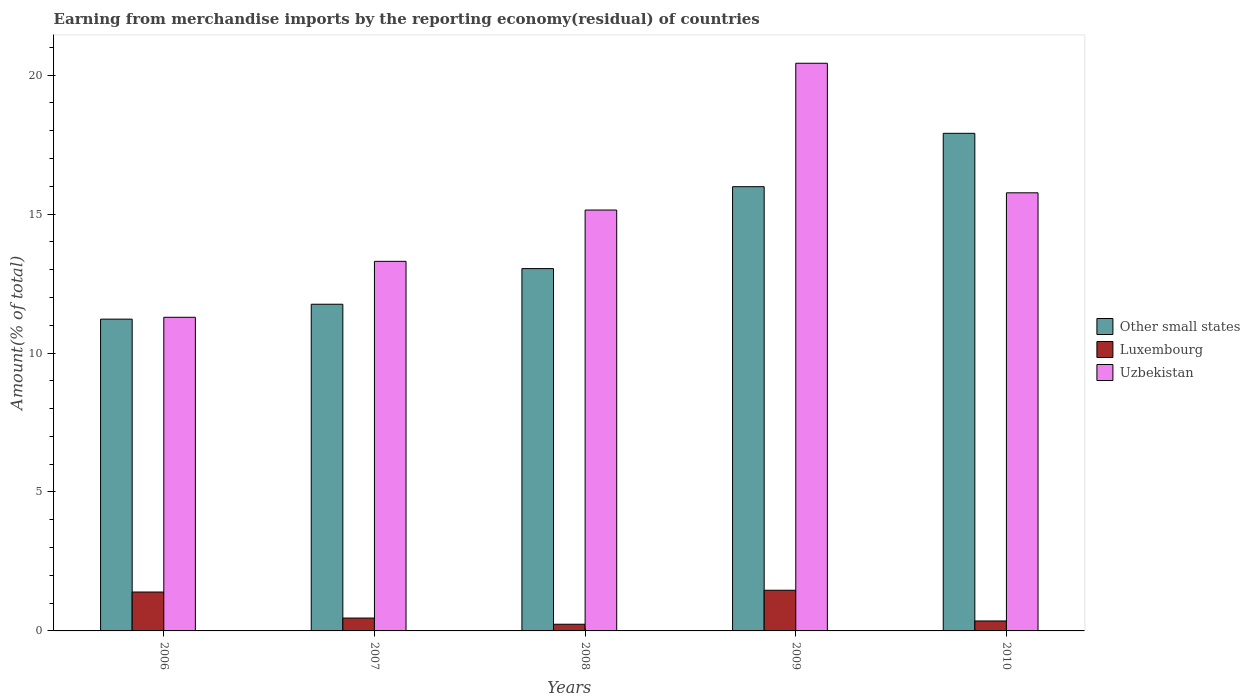How many different coloured bars are there?
Provide a short and direct response. 3. Are the number of bars on each tick of the X-axis equal?
Your response must be concise. Yes. What is the percentage of amount earned from merchandise imports in Other small states in 2009?
Provide a short and direct response. 15.99. Across all years, what is the maximum percentage of amount earned from merchandise imports in Luxembourg?
Give a very brief answer. 1.46. Across all years, what is the minimum percentage of amount earned from merchandise imports in Other small states?
Give a very brief answer. 11.22. In which year was the percentage of amount earned from merchandise imports in Uzbekistan minimum?
Keep it short and to the point. 2006. What is the total percentage of amount earned from merchandise imports in Other small states in the graph?
Your answer should be compact. 69.9. What is the difference between the percentage of amount earned from merchandise imports in Luxembourg in 2008 and that in 2010?
Keep it short and to the point. -0.12. What is the difference between the percentage of amount earned from merchandise imports in Other small states in 2007 and the percentage of amount earned from merchandise imports in Luxembourg in 2010?
Make the answer very short. 11.4. What is the average percentage of amount earned from merchandise imports in Luxembourg per year?
Offer a very short reply. 0.78. In the year 2007, what is the difference between the percentage of amount earned from merchandise imports in Uzbekistan and percentage of amount earned from merchandise imports in Other small states?
Keep it short and to the point. 1.54. What is the ratio of the percentage of amount earned from merchandise imports in Uzbekistan in 2009 to that in 2010?
Offer a very short reply. 1.3. Is the percentage of amount earned from merchandise imports in Luxembourg in 2007 less than that in 2010?
Offer a very short reply. No. Is the difference between the percentage of amount earned from merchandise imports in Uzbekistan in 2006 and 2010 greater than the difference between the percentage of amount earned from merchandise imports in Other small states in 2006 and 2010?
Provide a succinct answer. Yes. What is the difference between the highest and the second highest percentage of amount earned from merchandise imports in Uzbekistan?
Your answer should be compact. 4.66. What is the difference between the highest and the lowest percentage of amount earned from merchandise imports in Uzbekistan?
Offer a terse response. 9.14. In how many years, is the percentage of amount earned from merchandise imports in Luxembourg greater than the average percentage of amount earned from merchandise imports in Luxembourg taken over all years?
Give a very brief answer. 2. What does the 3rd bar from the left in 2009 represents?
Your answer should be compact. Uzbekistan. What does the 1st bar from the right in 2007 represents?
Provide a succinct answer. Uzbekistan. How many bars are there?
Ensure brevity in your answer.  15. What is the difference between two consecutive major ticks on the Y-axis?
Give a very brief answer. 5. Does the graph contain any zero values?
Your response must be concise. No. Where does the legend appear in the graph?
Offer a very short reply. Center right. How are the legend labels stacked?
Ensure brevity in your answer.  Vertical. What is the title of the graph?
Offer a very short reply. Earning from merchandise imports by the reporting economy(residual) of countries. Does "Rwanda" appear as one of the legend labels in the graph?
Make the answer very short. No. What is the label or title of the Y-axis?
Give a very brief answer. Amount(% of total). What is the Amount(% of total) in Other small states in 2006?
Your answer should be compact. 11.22. What is the Amount(% of total) of Luxembourg in 2006?
Ensure brevity in your answer.  1.4. What is the Amount(% of total) of Uzbekistan in 2006?
Offer a very short reply. 11.29. What is the Amount(% of total) in Other small states in 2007?
Give a very brief answer. 11.75. What is the Amount(% of total) of Luxembourg in 2007?
Ensure brevity in your answer.  0.46. What is the Amount(% of total) in Uzbekistan in 2007?
Make the answer very short. 13.3. What is the Amount(% of total) of Other small states in 2008?
Your answer should be very brief. 13.04. What is the Amount(% of total) in Luxembourg in 2008?
Your answer should be compact. 0.24. What is the Amount(% of total) of Uzbekistan in 2008?
Offer a very short reply. 15.14. What is the Amount(% of total) of Other small states in 2009?
Offer a terse response. 15.99. What is the Amount(% of total) of Luxembourg in 2009?
Offer a very short reply. 1.46. What is the Amount(% of total) of Uzbekistan in 2009?
Your response must be concise. 20.43. What is the Amount(% of total) of Other small states in 2010?
Offer a very short reply. 17.91. What is the Amount(% of total) of Luxembourg in 2010?
Provide a succinct answer. 0.36. What is the Amount(% of total) in Uzbekistan in 2010?
Offer a very short reply. 15.76. Across all years, what is the maximum Amount(% of total) of Other small states?
Provide a succinct answer. 17.91. Across all years, what is the maximum Amount(% of total) of Luxembourg?
Keep it short and to the point. 1.46. Across all years, what is the maximum Amount(% of total) in Uzbekistan?
Provide a short and direct response. 20.43. Across all years, what is the minimum Amount(% of total) in Other small states?
Your answer should be very brief. 11.22. Across all years, what is the minimum Amount(% of total) in Luxembourg?
Your answer should be very brief. 0.24. Across all years, what is the minimum Amount(% of total) of Uzbekistan?
Your answer should be very brief. 11.29. What is the total Amount(% of total) of Other small states in the graph?
Give a very brief answer. 69.9. What is the total Amount(% of total) of Luxembourg in the graph?
Offer a terse response. 3.92. What is the total Amount(% of total) in Uzbekistan in the graph?
Your answer should be very brief. 75.92. What is the difference between the Amount(% of total) of Other small states in 2006 and that in 2007?
Give a very brief answer. -0.54. What is the difference between the Amount(% of total) of Luxembourg in 2006 and that in 2007?
Your response must be concise. 0.94. What is the difference between the Amount(% of total) in Uzbekistan in 2006 and that in 2007?
Offer a terse response. -2.01. What is the difference between the Amount(% of total) in Other small states in 2006 and that in 2008?
Give a very brief answer. -1.82. What is the difference between the Amount(% of total) in Luxembourg in 2006 and that in 2008?
Offer a very short reply. 1.16. What is the difference between the Amount(% of total) of Uzbekistan in 2006 and that in 2008?
Provide a succinct answer. -3.86. What is the difference between the Amount(% of total) in Other small states in 2006 and that in 2009?
Your response must be concise. -4.77. What is the difference between the Amount(% of total) in Luxembourg in 2006 and that in 2009?
Ensure brevity in your answer.  -0.06. What is the difference between the Amount(% of total) of Uzbekistan in 2006 and that in 2009?
Ensure brevity in your answer.  -9.14. What is the difference between the Amount(% of total) of Other small states in 2006 and that in 2010?
Your answer should be compact. -6.69. What is the difference between the Amount(% of total) in Luxembourg in 2006 and that in 2010?
Your response must be concise. 1.04. What is the difference between the Amount(% of total) of Uzbekistan in 2006 and that in 2010?
Your answer should be very brief. -4.48. What is the difference between the Amount(% of total) in Other small states in 2007 and that in 2008?
Your response must be concise. -1.28. What is the difference between the Amount(% of total) in Luxembourg in 2007 and that in 2008?
Keep it short and to the point. 0.22. What is the difference between the Amount(% of total) of Uzbekistan in 2007 and that in 2008?
Your answer should be very brief. -1.85. What is the difference between the Amount(% of total) of Other small states in 2007 and that in 2009?
Provide a succinct answer. -4.23. What is the difference between the Amount(% of total) of Luxembourg in 2007 and that in 2009?
Ensure brevity in your answer.  -1. What is the difference between the Amount(% of total) in Uzbekistan in 2007 and that in 2009?
Your answer should be very brief. -7.13. What is the difference between the Amount(% of total) of Other small states in 2007 and that in 2010?
Ensure brevity in your answer.  -6.15. What is the difference between the Amount(% of total) in Luxembourg in 2007 and that in 2010?
Make the answer very short. 0.1. What is the difference between the Amount(% of total) of Uzbekistan in 2007 and that in 2010?
Give a very brief answer. -2.47. What is the difference between the Amount(% of total) in Other small states in 2008 and that in 2009?
Ensure brevity in your answer.  -2.95. What is the difference between the Amount(% of total) in Luxembourg in 2008 and that in 2009?
Make the answer very short. -1.22. What is the difference between the Amount(% of total) in Uzbekistan in 2008 and that in 2009?
Provide a succinct answer. -5.28. What is the difference between the Amount(% of total) in Other small states in 2008 and that in 2010?
Offer a very short reply. -4.87. What is the difference between the Amount(% of total) in Luxembourg in 2008 and that in 2010?
Keep it short and to the point. -0.12. What is the difference between the Amount(% of total) in Uzbekistan in 2008 and that in 2010?
Keep it short and to the point. -0.62. What is the difference between the Amount(% of total) in Other small states in 2009 and that in 2010?
Provide a short and direct response. -1.92. What is the difference between the Amount(% of total) in Luxembourg in 2009 and that in 2010?
Keep it short and to the point. 1.1. What is the difference between the Amount(% of total) in Uzbekistan in 2009 and that in 2010?
Provide a short and direct response. 4.66. What is the difference between the Amount(% of total) in Other small states in 2006 and the Amount(% of total) in Luxembourg in 2007?
Give a very brief answer. 10.76. What is the difference between the Amount(% of total) in Other small states in 2006 and the Amount(% of total) in Uzbekistan in 2007?
Make the answer very short. -2.08. What is the difference between the Amount(% of total) in Luxembourg in 2006 and the Amount(% of total) in Uzbekistan in 2007?
Provide a short and direct response. -11.9. What is the difference between the Amount(% of total) in Other small states in 2006 and the Amount(% of total) in Luxembourg in 2008?
Make the answer very short. 10.98. What is the difference between the Amount(% of total) in Other small states in 2006 and the Amount(% of total) in Uzbekistan in 2008?
Your answer should be compact. -3.93. What is the difference between the Amount(% of total) of Luxembourg in 2006 and the Amount(% of total) of Uzbekistan in 2008?
Provide a succinct answer. -13.74. What is the difference between the Amount(% of total) in Other small states in 2006 and the Amount(% of total) in Luxembourg in 2009?
Give a very brief answer. 9.75. What is the difference between the Amount(% of total) of Other small states in 2006 and the Amount(% of total) of Uzbekistan in 2009?
Offer a terse response. -9.21. What is the difference between the Amount(% of total) in Luxembourg in 2006 and the Amount(% of total) in Uzbekistan in 2009?
Offer a terse response. -19.03. What is the difference between the Amount(% of total) of Other small states in 2006 and the Amount(% of total) of Luxembourg in 2010?
Ensure brevity in your answer.  10.86. What is the difference between the Amount(% of total) of Other small states in 2006 and the Amount(% of total) of Uzbekistan in 2010?
Your answer should be compact. -4.55. What is the difference between the Amount(% of total) in Luxembourg in 2006 and the Amount(% of total) in Uzbekistan in 2010?
Provide a short and direct response. -14.37. What is the difference between the Amount(% of total) of Other small states in 2007 and the Amount(% of total) of Luxembourg in 2008?
Offer a terse response. 11.51. What is the difference between the Amount(% of total) in Other small states in 2007 and the Amount(% of total) in Uzbekistan in 2008?
Your answer should be compact. -3.39. What is the difference between the Amount(% of total) of Luxembourg in 2007 and the Amount(% of total) of Uzbekistan in 2008?
Your answer should be very brief. -14.68. What is the difference between the Amount(% of total) of Other small states in 2007 and the Amount(% of total) of Luxembourg in 2009?
Offer a terse response. 10.29. What is the difference between the Amount(% of total) in Other small states in 2007 and the Amount(% of total) in Uzbekistan in 2009?
Your response must be concise. -8.67. What is the difference between the Amount(% of total) of Luxembourg in 2007 and the Amount(% of total) of Uzbekistan in 2009?
Give a very brief answer. -19.96. What is the difference between the Amount(% of total) of Other small states in 2007 and the Amount(% of total) of Luxembourg in 2010?
Keep it short and to the point. 11.4. What is the difference between the Amount(% of total) in Other small states in 2007 and the Amount(% of total) in Uzbekistan in 2010?
Your answer should be compact. -4.01. What is the difference between the Amount(% of total) in Luxembourg in 2007 and the Amount(% of total) in Uzbekistan in 2010?
Keep it short and to the point. -15.3. What is the difference between the Amount(% of total) in Other small states in 2008 and the Amount(% of total) in Luxembourg in 2009?
Your answer should be very brief. 11.57. What is the difference between the Amount(% of total) in Other small states in 2008 and the Amount(% of total) in Uzbekistan in 2009?
Your answer should be very brief. -7.39. What is the difference between the Amount(% of total) of Luxembourg in 2008 and the Amount(% of total) of Uzbekistan in 2009?
Offer a very short reply. -20.19. What is the difference between the Amount(% of total) in Other small states in 2008 and the Amount(% of total) in Luxembourg in 2010?
Offer a very short reply. 12.68. What is the difference between the Amount(% of total) of Other small states in 2008 and the Amount(% of total) of Uzbekistan in 2010?
Keep it short and to the point. -2.73. What is the difference between the Amount(% of total) of Luxembourg in 2008 and the Amount(% of total) of Uzbekistan in 2010?
Provide a short and direct response. -15.52. What is the difference between the Amount(% of total) in Other small states in 2009 and the Amount(% of total) in Luxembourg in 2010?
Offer a terse response. 15.63. What is the difference between the Amount(% of total) of Other small states in 2009 and the Amount(% of total) of Uzbekistan in 2010?
Your answer should be very brief. 0.22. What is the difference between the Amount(% of total) of Luxembourg in 2009 and the Amount(% of total) of Uzbekistan in 2010?
Give a very brief answer. -14.3. What is the average Amount(% of total) in Other small states per year?
Give a very brief answer. 13.98. What is the average Amount(% of total) of Luxembourg per year?
Provide a short and direct response. 0.78. What is the average Amount(% of total) of Uzbekistan per year?
Your answer should be very brief. 15.18. In the year 2006, what is the difference between the Amount(% of total) of Other small states and Amount(% of total) of Luxembourg?
Your response must be concise. 9.82. In the year 2006, what is the difference between the Amount(% of total) in Other small states and Amount(% of total) in Uzbekistan?
Your response must be concise. -0.07. In the year 2006, what is the difference between the Amount(% of total) of Luxembourg and Amount(% of total) of Uzbekistan?
Your response must be concise. -9.89. In the year 2007, what is the difference between the Amount(% of total) of Other small states and Amount(% of total) of Luxembourg?
Your response must be concise. 11.29. In the year 2007, what is the difference between the Amount(% of total) in Other small states and Amount(% of total) in Uzbekistan?
Offer a terse response. -1.54. In the year 2007, what is the difference between the Amount(% of total) of Luxembourg and Amount(% of total) of Uzbekistan?
Keep it short and to the point. -12.84. In the year 2008, what is the difference between the Amount(% of total) of Other small states and Amount(% of total) of Luxembourg?
Offer a terse response. 12.8. In the year 2008, what is the difference between the Amount(% of total) in Other small states and Amount(% of total) in Uzbekistan?
Your response must be concise. -2.11. In the year 2008, what is the difference between the Amount(% of total) in Luxembourg and Amount(% of total) in Uzbekistan?
Provide a succinct answer. -14.9. In the year 2009, what is the difference between the Amount(% of total) in Other small states and Amount(% of total) in Luxembourg?
Your answer should be very brief. 14.52. In the year 2009, what is the difference between the Amount(% of total) of Other small states and Amount(% of total) of Uzbekistan?
Give a very brief answer. -4.44. In the year 2009, what is the difference between the Amount(% of total) of Luxembourg and Amount(% of total) of Uzbekistan?
Offer a very short reply. -18.96. In the year 2010, what is the difference between the Amount(% of total) in Other small states and Amount(% of total) in Luxembourg?
Offer a very short reply. 17.55. In the year 2010, what is the difference between the Amount(% of total) in Other small states and Amount(% of total) in Uzbekistan?
Your response must be concise. 2.14. In the year 2010, what is the difference between the Amount(% of total) of Luxembourg and Amount(% of total) of Uzbekistan?
Your answer should be very brief. -15.41. What is the ratio of the Amount(% of total) in Other small states in 2006 to that in 2007?
Your answer should be very brief. 0.95. What is the ratio of the Amount(% of total) in Luxembourg in 2006 to that in 2007?
Provide a short and direct response. 3.02. What is the ratio of the Amount(% of total) in Uzbekistan in 2006 to that in 2007?
Offer a very short reply. 0.85. What is the ratio of the Amount(% of total) of Other small states in 2006 to that in 2008?
Ensure brevity in your answer.  0.86. What is the ratio of the Amount(% of total) in Luxembourg in 2006 to that in 2008?
Provide a succinct answer. 5.83. What is the ratio of the Amount(% of total) in Uzbekistan in 2006 to that in 2008?
Your answer should be very brief. 0.75. What is the ratio of the Amount(% of total) of Other small states in 2006 to that in 2009?
Offer a very short reply. 0.7. What is the ratio of the Amount(% of total) in Luxembourg in 2006 to that in 2009?
Your answer should be very brief. 0.96. What is the ratio of the Amount(% of total) of Uzbekistan in 2006 to that in 2009?
Keep it short and to the point. 0.55. What is the ratio of the Amount(% of total) in Other small states in 2006 to that in 2010?
Your response must be concise. 0.63. What is the ratio of the Amount(% of total) in Luxembourg in 2006 to that in 2010?
Keep it short and to the point. 3.9. What is the ratio of the Amount(% of total) in Uzbekistan in 2006 to that in 2010?
Give a very brief answer. 0.72. What is the ratio of the Amount(% of total) in Other small states in 2007 to that in 2008?
Ensure brevity in your answer.  0.9. What is the ratio of the Amount(% of total) of Luxembourg in 2007 to that in 2008?
Your answer should be very brief. 1.93. What is the ratio of the Amount(% of total) of Uzbekistan in 2007 to that in 2008?
Give a very brief answer. 0.88. What is the ratio of the Amount(% of total) of Other small states in 2007 to that in 2009?
Offer a terse response. 0.74. What is the ratio of the Amount(% of total) in Luxembourg in 2007 to that in 2009?
Your response must be concise. 0.32. What is the ratio of the Amount(% of total) of Uzbekistan in 2007 to that in 2009?
Offer a terse response. 0.65. What is the ratio of the Amount(% of total) of Other small states in 2007 to that in 2010?
Make the answer very short. 0.66. What is the ratio of the Amount(% of total) in Luxembourg in 2007 to that in 2010?
Provide a short and direct response. 1.29. What is the ratio of the Amount(% of total) in Uzbekistan in 2007 to that in 2010?
Ensure brevity in your answer.  0.84. What is the ratio of the Amount(% of total) of Other small states in 2008 to that in 2009?
Provide a succinct answer. 0.82. What is the ratio of the Amount(% of total) in Luxembourg in 2008 to that in 2009?
Offer a terse response. 0.16. What is the ratio of the Amount(% of total) in Uzbekistan in 2008 to that in 2009?
Your answer should be very brief. 0.74. What is the ratio of the Amount(% of total) of Other small states in 2008 to that in 2010?
Your answer should be compact. 0.73. What is the ratio of the Amount(% of total) of Luxembourg in 2008 to that in 2010?
Your answer should be very brief. 0.67. What is the ratio of the Amount(% of total) in Uzbekistan in 2008 to that in 2010?
Keep it short and to the point. 0.96. What is the ratio of the Amount(% of total) of Other small states in 2009 to that in 2010?
Your answer should be very brief. 0.89. What is the ratio of the Amount(% of total) in Luxembourg in 2009 to that in 2010?
Make the answer very short. 4.08. What is the ratio of the Amount(% of total) of Uzbekistan in 2009 to that in 2010?
Your response must be concise. 1.3. What is the difference between the highest and the second highest Amount(% of total) of Other small states?
Provide a succinct answer. 1.92. What is the difference between the highest and the second highest Amount(% of total) of Luxembourg?
Your response must be concise. 0.06. What is the difference between the highest and the second highest Amount(% of total) of Uzbekistan?
Give a very brief answer. 4.66. What is the difference between the highest and the lowest Amount(% of total) of Other small states?
Offer a terse response. 6.69. What is the difference between the highest and the lowest Amount(% of total) in Luxembourg?
Make the answer very short. 1.22. What is the difference between the highest and the lowest Amount(% of total) of Uzbekistan?
Offer a terse response. 9.14. 